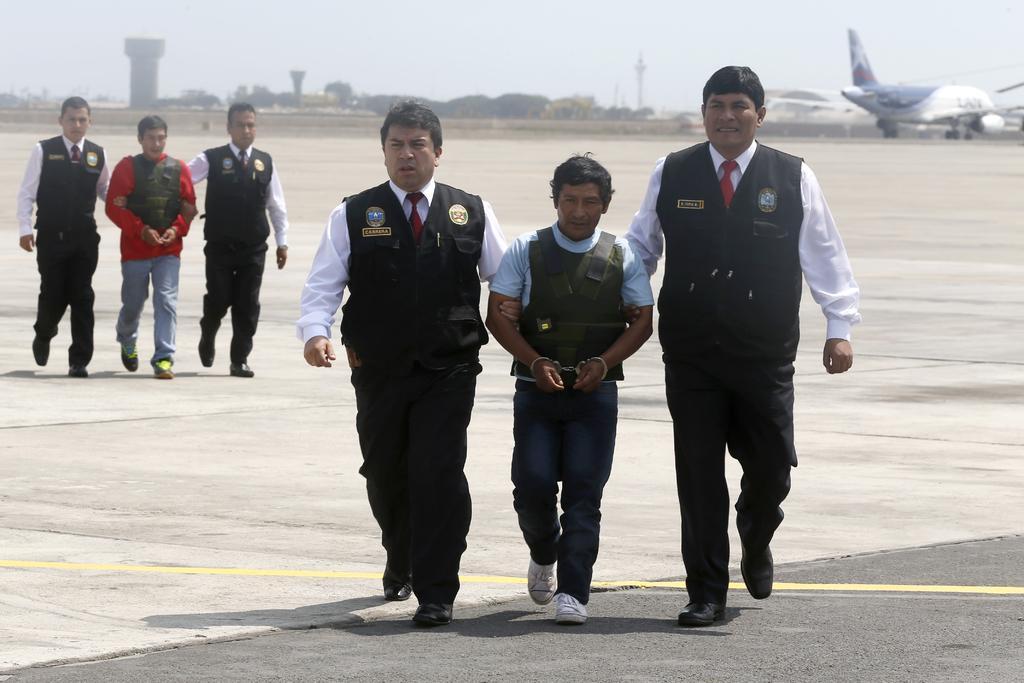Could you give a brief overview of what you see in this image? In the picture we can see group of people walking along the floor and in the background of the picture there is an airplane and there are some trees, top of the picture there is clear sky. 